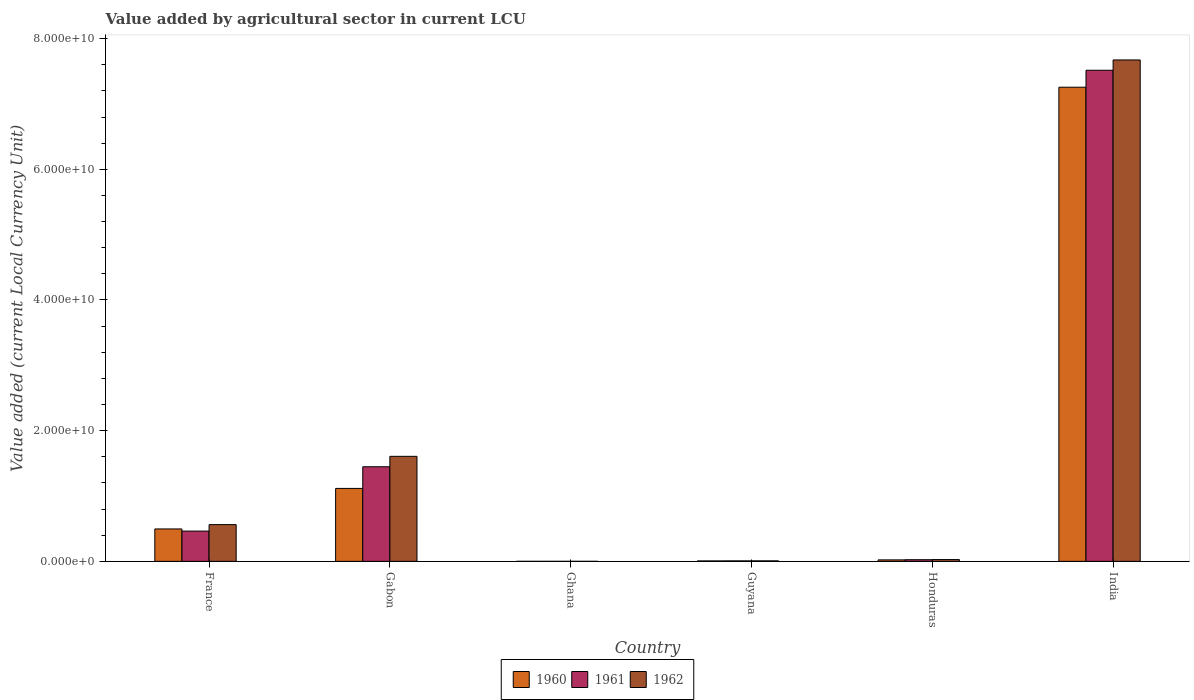How many groups of bars are there?
Offer a terse response. 6. Are the number of bars per tick equal to the number of legend labels?
Give a very brief answer. Yes. Are the number of bars on each tick of the X-axis equal?
Give a very brief answer. Yes. How many bars are there on the 4th tick from the left?
Ensure brevity in your answer.  3. How many bars are there on the 3rd tick from the right?
Provide a short and direct response. 3. What is the label of the 2nd group of bars from the left?
Your answer should be very brief. Gabon. What is the value added by agricultural sector in 1960 in India?
Your answer should be very brief. 7.26e+1. Across all countries, what is the maximum value added by agricultural sector in 1960?
Keep it short and to the point. 7.26e+1. Across all countries, what is the minimum value added by agricultural sector in 1960?
Provide a succinct answer. 3.55e+04. In which country was the value added by agricultural sector in 1962 maximum?
Your answer should be compact. India. In which country was the value added by agricultural sector in 1962 minimum?
Ensure brevity in your answer.  Ghana. What is the total value added by agricultural sector in 1962 in the graph?
Your answer should be compact. 9.88e+1. What is the difference between the value added by agricultural sector in 1961 in Gabon and that in India?
Provide a short and direct response. -6.07e+1. What is the difference between the value added by agricultural sector in 1960 in Ghana and the value added by agricultural sector in 1961 in India?
Provide a succinct answer. -7.52e+1. What is the average value added by agricultural sector in 1960 per country?
Your response must be concise. 1.48e+1. What is the difference between the value added by agricultural sector of/in 1962 and value added by agricultural sector of/in 1961 in France?
Your response must be concise. 9.90e+08. What is the ratio of the value added by agricultural sector in 1961 in Honduras to that in India?
Provide a succinct answer. 0. Is the value added by agricultural sector in 1960 in Gabon less than that in Ghana?
Make the answer very short. No. What is the difference between the highest and the second highest value added by agricultural sector in 1960?
Make the answer very short. 6.14e+1. What is the difference between the highest and the lowest value added by agricultural sector in 1962?
Ensure brevity in your answer.  7.67e+1. In how many countries, is the value added by agricultural sector in 1961 greater than the average value added by agricultural sector in 1961 taken over all countries?
Provide a short and direct response. 1. Is the sum of the value added by agricultural sector in 1960 in Gabon and India greater than the maximum value added by agricultural sector in 1961 across all countries?
Offer a terse response. Yes. What does the 1st bar from the left in Ghana represents?
Your response must be concise. 1960. What does the 2nd bar from the right in France represents?
Provide a short and direct response. 1961. Is it the case that in every country, the sum of the value added by agricultural sector in 1962 and value added by agricultural sector in 1961 is greater than the value added by agricultural sector in 1960?
Keep it short and to the point. Yes. Are all the bars in the graph horizontal?
Provide a short and direct response. No. How many countries are there in the graph?
Your answer should be very brief. 6. Are the values on the major ticks of Y-axis written in scientific E-notation?
Keep it short and to the point. Yes. Does the graph contain grids?
Offer a very short reply. No. How are the legend labels stacked?
Give a very brief answer. Horizontal. What is the title of the graph?
Your answer should be compact. Value added by agricultural sector in current LCU. What is the label or title of the Y-axis?
Your answer should be very brief. Value added (current Local Currency Unit). What is the Value added (current Local Currency Unit) of 1960 in France?
Make the answer very short. 4.96e+09. What is the Value added (current Local Currency Unit) in 1961 in France?
Your answer should be very brief. 4.63e+09. What is the Value added (current Local Currency Unit) of 1962 in France?
Your response must be concise. 5.62e+09. What is the Value added (current Local Currency Unit) of 1960 in Gabon?
Ensure brevity in your answer.  1.12e+1. What is the Value added (current Local Currency Unit) in 1961 in Gabon?
Offer a terse response. 1.45e+1. What is the Value added (current Local Currency Unit) in 1962 in Gabon?
Keep it short and to the point. 1.61e+1. What is the Value added (current Local Currency Unit) in 1960 in Ghana?
Offer a terse response. 3.55e+04. What is the Value added (current Local Currency Unit) of 1961 in Ghana?
Make the answer very short. 3.29e+04. What is the Value added (current Local Currency Unit) of 1962 in Ghana?
Make the answer very short. 3.74e+04. What is the Value added (current Local Currency Unit) in 1960 in Guyana?
Keep it short and to the point. 6.88e+07. What is the Value added (current Local Currency Unit) of 1961 in Guyana?
Offer a very short reply. 7.60e+07. What is the Value added (current Local Currency Unit) of 1962 in Guyana?
Your response must be concise. 7.84e+07. What is the Value added (current Local Currency Unit) in 1960 in Honduras?
Offer a very short reply. 2.27e+08. What is the Value added (current Local Currency Unit) in 1961 in Honduras?
Keep it short and to the point. 2.51e+08. What is the Value added (current Local Currency Unit) of 1962 in Honduras?
Your response must be concise. 2.74e+08. What is the Value added (current Local Currency Unit) of 1960 in India?
Offer a terse response. 7.26e+1. What is the Value added (current Local Currency Unit) in 1961 in India?
Provide a succinct answer. 7.52e+1. What is the Value added (current Local Currency Unit) of 1962 in India?
Ensure brevity in your answer.  7.67e+1. Across all countries, what is the maximum Value added (current Local Currency Unit) in 1960?
Offer a terse response. 7.26e+1. Across all countries, what is the maximum Value added (current Local Currency Unit) in 1961?
Your response must be concise. 7.52e+1. Across all countries, what is the maximum Value added (current Local Currency Unit) in 1962?
Keep it short and to the point. 7.67e+1. Across all countries, what is the minimum Value added (current Local Currency Unit) in 1960?
Your answer should be very brief. 3.55e+04. Across all countries, what is the minimum Value added (current Local Currency Unit) of 1961?
Ensure brevity in your answer.  3.29e+04. Across all countries, what is the minimum Value added (current Local Currency Unit) in 1962?
Provide a short and direct response. 3.74e+04. What is the total Value added (current Local Currency Unit) of 1960 in the graph?
Provide a short and direct response. 8.90e+1. What is the total Value added (current Local Currency Unit) in 1961 in the graph?
Keep it short and to the point. 9.46e+1. What is the total Value added (current Local Currency Unit) in 1962 in the graph?
Ensure brevity in your answer.  9.88e+1. What is the difference between the Value added (current Local Currency Unit) of 1960 in France and that in Gabon?
Your answer should be very brief. -6.20e+09. What is the difference between the Value added (current Local Currency Unit) in 1961 in France and that in Gabon?
Make the answer very short. -9.84e+09. What is the difference between the Value added (current Local Currency Unit) in 1962 in France and that in Gabon?
Your answer should be very brief. -1.04e+1. What is the difference between the Value added (current Local Currency Unit) in 1960 in France and that in Ghana?
Provide a succinct answer. 4.96e+09. What is the difference between the Value added (current Local Currency Unit) of 1961 in France and that in Ghana?
Provide a short and direct response. 4.63e+09. What is the difference between the Value added (current Local Currency Unit) in 1962 in France and that in Ghana?
Give a very brief answer. 5.62e+09. What is the difference between the Value added (current Local Currency Unit) of 1960 in France and that in Guyana?
Keep it short and to the point. 4.89e+09. What is the difference between the Value added (current Local Currency Unit) in 1961 in France and that in Guyana?
Offer a terse response. 4.56e+09. What is the difference between the Value added (current Local Currency Unit) in 1962 in France and that in Guyana?
Provide a succinct answer. 5.55e+09. What is the difference between the Value added (current Local Currency Unit) of 1960 in France and that in Honduras?
Offer a terse response. 4.73e+09. What is the difference between the Value added (current Local Currency Unit) of 1961 in France and that in Honduras?
Offer a very short reply. 4.38e+09. What is the difference between the Value added (current Local Currency Unit) of 1962 in France and that in Honduras?
Make the answer very short. 5.35e+09. What is the difference between the Value added (current Local Currency Unit) in 1960 in France and that in India?
Keep it short and to the point. -6.76e+1. What is the difference between the Value added (current Local Currency Unit) of 1961 in France and that in India?
Offer a terse response. -7.05e+1. What is the difference between the Value added (current Local Currency Unit) in 1962 in France and that in India?
Offer a terse response. -7.11e+1. What is the difference between the Value added (current Local Currency Unit) of 1960 in Gabon and that in Ghana?
Your response must be concise. 1.12e+1. What is the difference between the Value added (current Local Currency Unit) in 1961 in Gabon and that in Ghana?
Provide a succinct answer. 1.45e+1. What is the difference between the Value added (current Local Currency Unit) in 1962 in Gabon and that in Ghana?
Your response must be concise. 1.61e+1. What is the difference between the Value added (current Local Currency Unit) of 1960 in Gabon and that in Guyana?
Provide a short and direct response. 1.11e+1. What is the difference between the Value added (current Local Currency Unit) of 1961 in Gabon and that in Guyana?
Your answer should be very brief. 1.44e+1. What is the difference between the Value added (current Local Currency Unit) of 1962 in Gabon and that in Guyana?
Provide a succinct answer. 1.60e+1. What is the difference between the Value added (current Local Currency Unit) of 1960 in Gabon and that in Honduras?
Ensure brevity in your answer.  1.09e+1. What is the difference between the Value added (current Local Currency Unit) of 1961 in Gabon and that in Honduras?
Make the answer very short. 1.42e+1. What is the difference between the Value added (current Local Currency Unit) in 1962 in Gabon and that in Honduras?
Offer a terse response. 1.58e+1. What is the difference between the Value added (current Local Currency Unit) in 1960 in Gabon and that in India?
Make the answer very short. -6.14e+1. What is the difference between the Value added (current Local Currency Unit) of 1961 in Gabon and that in India?
Give a very brief answer. -6.07e+1. What is the difference between the Value added (current Local Currency Unit) of 1962 in Gabon and that in India?
Provide a short and direct response. -6.07e+1. What is the difference between the Value added (current Local Currency Unit) in 1960 in Ghana and that in Guyana?
Offer a very short reply. -6.88e+07. What is the difference between the Value added (current Local Currency Unit) of 1961 in Ghana and that in Guyana?
Your answer should be compact. -7.60e+07. What is the difference between the Value added (current Local Currency Unit) of 1962 in Ghana and that in Guyana?
Provide a succinct answer. -7.84e+07. What is the difference between the Value added (current Local Currency Unit) in 1960 in Ghana and that in Honduras?
Provide a short and direct response. -2.27e+08. What is the difference between the Value added (current Local Currency Unit) in 1961 in Ghana and that in Honduras?
Ensure brevity in your answer.  -2.51e+08. What is the difference between the Value added (current Local Currency Unit) of 1962 in Ghana and that in Honduras?
Provide a short and direct response. -2.74e+08. What is the difference between the Value added (current Local Currency Unit) in 1960 in Ghana and that in India?
Offer a very short reply. -7.26e+1. What is the difference between the Value added (current Local Currency Unit) in 1961 in Ghana and that in India?
Make the answer very short. -7.52e+1. What is the difference between the Value added (current Local Currency Unit) in 1962 in Ghana and that in India?
Keep it short and to the point. -7.67e+1. What is the difference between the Value added (current Local Currency Unit) of 1960 in Guyana and that in Honduras?
Your response must be concise. -1.58e+08. What is the difference between the Value added (current Local Currency Unit) in 1961 in Guyana and that in Honduras?
Ensure brevity in your answer.  -1.75e+08. What is the difference between the Value added (current Local Currency Unit) of 1962 in Guyana and that in Honduras?
Provide a succinct answer. -1.96e+08. What is the difference between the Value added (current Local Currency Unit) of 1960 in Guyana and that in India?
Your response must be concise. -7.25e+1. What is the difference between the Value added (current Local Currency Unit) of 1961 in Guyana and that in India?
Give a very brief answer. -7.51e+1. What is the difference between the Value added (current Local Currency Unit) of 1962 in Guyana and that in India?
Keep it short and to the point. -7.67e+1. What is the difference between the Value added (current Local Currency Unit) in 1960 in Honduras and that in India?
Ensure brevity in your answer.  -7.23e+1. What is the difference between the Value added (current Local Currency Unit) in 1961 in Honduras and that in India?
Your answer should be compact. -7.49e+1. What is the difference between the Value added (current Local Currency Unit) of 1962 in Honduras and that in India?
Your answer should be compact. -7.65e+1. What is the difference between the Value added (current Local Currency Unit) of 1960 in France and the Value added (current Local Currency Unit) of 1961 in Gabon?
Provide a succinct answer. -9.52e+09. What is the difference between the Value added (current Local Currency Unit) of 1960 in France and the Value added (current Local Currency Unit) of 1962 in Gabon?
Offer a terse response. -1.11e+1. What is the difference between the Value added (current Local Currency Unit) of 1961 in France and the Value added (current Local Currency Unit) of 1962 in Gabon?
Provide a short and direct response. -1.14e+1. What is the difference between the Value added (current Local Currency Unit) in 1960 in France and the Value added (current Local Currency Unit) in 1961 in Ghana?
Provide a succinct answer. 4.96e+09. What is the difference between the Value added (current Local Currency Unit) in 1960 in France and the Value added (current Local Currency Unit) in 1962 in Ghana?
Offer a very short reply. 4.96e+09. What is the difference between the Value added (current Local Currency Unit) in 1961 in France and the Value added (current Local Currency Unit) in 1962 in Ghana?
Keep it short and to the point. 4.63e+09. What is the difference between the Value added (current Local Currency Unit) of 1960 in France and the Value added (current Local Currency Unit) of 1961 in Guyana?
Your answer should be very brief. 4.88e+09. What is the difference between the Value added (current Local Currency Unit) of 1960 in France and the Value added (current Local Currency Unit) of 1962 in Guyana?
Your answer should be very brief. 4.88e+09. What is the difference between the Value added (current Local Currency Unit) of 1961 in France and the Value added (current Local Currency Unit) of 1962 in Guyana?
Your answer should be very brief. 4.56e+09. What is the difference between the Value added (current Local Currency Unit) in 1960 in France and the Value added (current Local Currency Unit) in 1961 in Honduras?
Ensure brevity in your answer.  4.71e+09. What is the difference between the Value added (current Local Currency Unit) in 1960 in France and the Value added (current Local Currency Unit) in 1962 in Honduras?
Your answer should be very brief. 4.69e+09. What is the difference between the Value added (current Local Currency Unit) in 1961 in France and the Value added (current Local Currency Unit) in 1962 in Honduras?
Your answer should be compact. 4.36e+09. What is the difference between the Value added (current Local Currency Unit) in 1960 in France and the Value added (current Local Currency Unit) in 1961 in India?
Make the answer very short. -7.02e+1. What is the difference between the Value added (current Local Currency Unit) in 1960 in France and the Value added (current Local Currency Unit) in 1962 in India?
Make the answer very short. -7.18e+1. What is the difference between the Value added (current Local Currency Unit) of 1961 in France and the Value added (current Local Currency Unit) of 1962 in India?
Make the answer very short. -7.21e+1. What is the difference between the Value added (current Local Currency Unit) in 1960 in Gabon and the Value added (current Local Currency Unit) in 1961 in Ghana?
Provide a succinct answer. 1.12e+1. What is the difference between the Value added (current Local Currency Unit) in 1960 in Gabon and the Value added (current Local Currency Unit) in 1962 in Ghana?
Your answer should be very brief. 1.12e+1. What is the difference between the Value added (current Local Currency Unit) of 1961 in Gabon and the Value added (current Local Currency Unit) of 1962 in Ghana?
Give a very brief answer. 1.45e+1. What is the difference between the Value added (current Local Currency Unit) of 1960 in Gabon and the Value added (current Local Currency Unit) of 1961 in Guyana?
Provide a short and direct response. 1.11e+1. What is the difference between the Value added (current Local Currency Unit) of 1960 in Gabon and the Value added (current Local Currency Unit) of 1962 in Guyana?
Ensure brevity in your answer.  1.11e+1. What is the difference between the Value added (current Local Currency Unit) in 1961 in Gabon and the Value added (current Local Currency Unit) in 1962 in Guyana?
Your response must be concise. 1.44e+1. What is the difference between the Value added (current Local Currency Unit) in 1960 in Gabon and the Value added (current Local Currency Unit) in 1961 in Honduras?
Your response must be concise. 1.09e+1. What is the difference between the Value added (current Local Currency Unit) of 1960 in Gabon and the Value added (current Local Currency Unit) of 1962 in Honduras?
Give a very brief answer. 1.09e+1. What is the difference between the Value added (current Local Currency Unit) in 1961 in Gabon and the Value added (current Local Currency Unit) in 1962 in Honduras?
Make the answer very short. 1.42e+1. What is the difference between the Value added (current Local Currency Unit) in 1960 in Gabon and the Value added (current Local Currency Unit) in 1961 in India?
Your answer should be very brief. -6.40e+1. What is the difference between the Value added (current Local Currency Unit) in 1960 in Gabon and the Value added (current Local Currency Unit) in 1962 in India?
Your response must be concise. -6.56e+1. What is the difference between the Value added (current Local Currency Unit) in 1961 in Gabon and the Value added (current Local Currency Unit) in 1962 in India?
Ensure brevity in your answer.  -6.23e+1. What is the difference between the Value added (current Local Currency Unit) in 1960 in Ghana and the Value added (current Local Currency Unit) in 1961 in Guyana?
Keep it short and to the point. -7.60e+07. What is the difference between the Value added (current Local Currency Unit) in 1960 in Ghana and the Value added (current Local Currency Unit) in 1962 in Guyana?
Offer a very short reply. -7.84e+07. What is the difference between the Value added (current Local Currency Unit) of 1961 in Ghana and the Value added (current Local Currency Unit) of 1962 in Guyana?
Provide a short and direct response. -7.84e+07. What is the difference between the Value added (current Local Currency Unit) of 1960 in Ghana and the Value added (current Local Currency Unit) of 1961 in Honduras?
Offer a terse response. -2.51e+08. What is the difference between the Value added (current Local Currency Unit) in 1960 in Ghana and the Value added (current Local Currency Unit) in 1962 in Honduras?
Give a very brief answer. -2.74e+08. What is the difference between the Value added (current Local Currency Unit) of 1961 in Ghana and the Value added (current Local Currency Unit) of 1962 in Honduras?
Your answer should be very brief. -2.74e+08. What is the difference between the Value added (current Local Currency Unit) of 1960 in Ghana and the Value added (current Local Currency Unit) of 1961 in India?
Your answer should be very brief. -7.52e+1. What is the difference between the Value added (current Local Currency Unit) of 1960 in Ghana and the Value added (current Local Currency Unit) of 1962 in India?
Provide a short and direct response. -7.67e+1. What is the difference between the Value added (current Local Currency Unit) in 1961 in Ghana and the Value added (current Local Currency Unit) in 1962 in India?
Your answer should be compact. -7.67e+1. What is the difference between the Value added (current Local Currency Unit) of 1960 in Guyana and the Value added (current Local Currency Unit) of 1961 in Honduras?
Offer a very short reply. -1.82e+08. What is the difference between the Value added (current Local Currency Unit) of 1960 in Guyana and the Value added (current Local Currency Unit) of 1962 in Honduras?
Provide a succinct answer. -2.06e+08. What is the difference between the Value added (current Local Currency Unit) in 1961 in Guyana and the Value added (current Local Currency Unit) in 1962 in Honduras?
Ensure brevity in your answer.  -1.98e+08. What is the difference between the Value added (current Local Currency Unit) in 1960 in Guyana and the Value added (current Local Currency Unit) in 1961 in India?
Offer a very short reply. -7.51e+1. What is the difference between the Value added (current Local Currency Unit) of 1960 in Guyana and the Value added (current Local Currency Unit) of 1962 in India?
Your answer should be very brief. -7.67e+1. What is the difference between the Value added (current Local Currency Unit) in 1961 in Guyana and the Value added (current Local Currency Unit) in 1962 in India?
Give a very brief answer. -7.67e+1. What is the difference between the Value added (current Local Currency Unit) in 1960 in Honduras and the Value added (current Local Currency Unit) in 1961 in India?
Offer a terse response. -7.49e+1. What is the difference between the Value added (current Local Currency Unit) of 1960 in Honduras and the Value added (current Local Currency Unit) of 1962 in India?
Your answer should be compact. -7.65e+1. What is the difference between the Value added (current Local Currency Unit) in 1961 in Honduras and the Value added (current Local Currency Unit) in 1962 in India?
Provide a short and direct response. -7.65e+1. What is the average Value added (current Local Currency Unit) in 1960 per country?
Your answer should be compact. 1.48e+1. What is the average Value added (current Local Currency Unit) in 1961 per country?
Your answer should be very brief. 1.58e+1. What is the average Value added (current Local Currency Unit) in 1962 per country?
Offer a terse response. 1.65e+1. What is the difference between the Value added (current Local Currency Unit) in 1960 and Value added (current Local Currency Unit) in 1961 in France?
Keep it short and to the point. 3.26e+08. What is the difference between the Value added (current Local Currency Unit) in 1960 and Value added (current Local Currency Unit) in 1962 in France?
Your response must be concise. -6.64e+08. What is the difference between the Value added (current Local Currency Unit) in 1961 and Value added (current Local Currency Unit) in 1962 in France?
Keep it short and to the point. -9.90e+08. What is the difference between the Value added (current Local Currency Unit) of 1960 and Value added (current Local Currency Unit) of 1961 in Gabon?
Make the answer very short. -3.31e+09. What is the difference between the Value added (current Local Currency Unit) of 1960 and Value added (current Local Currency Unit) of 1962 in Gabon?
Keep it short and to the point. -4.91e+09. What is the difference between the Value added (current Local Currency Unit) in 1961 and Value added (current Local Currency Unit) in 1962 in Gabon?
Give a very brief answer. -1.59e+09. What is the difference between the Value added (current Local Currency Unit) in 1960 and Value added (current Local Currency Unit) in 1961 in Ghana?
Your answer should be very brief. 2600. What is the difference between the Value added (current Local Currency Unit) in 1960 and Value added (current Local Currency Unit) in 1962 in Ghana?
Your answer should be very brief. -1900. What is the difference between the Value added (current Local Currency Unit) in 1961 and Value added (current Local Currency Unit) in 1962 in Ghana?
Ensure brevity in your answer.  -4500. What is the difference between the Value added (current Local Currency Unit) of 1960 and Value added (current Local Currency Unit) of 1961 in Guyana?
Give a very brief answer. -7.20e+06. What is the difference between the Value added (current Local Currency Unit) of 1960 and Value added (current Local Currency Unit) of 1962 in Guyana?
Your response must be concise. -9.60e+06. What is the difference between the Value added (current Local Currency Unit) of 1961 and Value added (current Local Currency Unit) of 1962 in Guyana?
Offer a terse response. -2.40e+06. What is the difference between the Value added (current Local Currency Unit) in 1960 and Value added (current Local Currency Unit) in 1961 in Honduras?
Offer a terse response. -2.42e+07. What is the difference between the Value added (current Local Currency Unit) of 1960 and Value added (current Local Currency Unit) of 1962 in Honduras?
Give a very brief answer. -4.75e+07. What is the difference between the Value added (current Local Currency Unit) of 1961 and Value added (current Local Currency Unit) of 1962 in Honduras?
Your answer should be very brief. -2.33e+07. What is the difference between the Value added (current Local Currency Unit) in 1960 and Value added (current Local Currency Unit) in 1961 in India?
Offer a terse response. -2.59e+09. What is the difference between the Value added (current Local Currency Unit) in 1960 and Value added (current Local Currency Unit) in 1962 in India?
Give a very brief answer. -4.17e+09. What is the difference between the Value added (current Local Currency Unit) of 1961 and Value added (current Local Currency Unit) of 1962 in India?
Offer a very short reply. -1.58e+09. What is the ratio of the Value added (current Local Currency Unit) in 1960 in France to that in Gabon?
Offer a terse response. 0.44. What is the ratio of the Value added (current Local Currency Unit) in 1961 in France to that in Gabon?
Your answer should be compact. 0.32. What is the ratio of the Value added (current Local Currency Unit) in 1962 in France to that in Gabon?
Provide a short and direct response. 0.35. What is the ratio of the Value added (current Local Currency Unit) in 1960 in France to that in Ghana?
Offer a very short reply. 1.40e+05. What is the ratio of the Value added (current Local Currency Unit) of 1961 in France to that in Ghana?
Offer a very short reply. 1.41e+05. What is the ratio of the Value added (current Local Currency Unit) in 1962 in France to that in Ghana?
Provide a short and direct response. 1.50e+05. What is the ratio of the Value added (current Local Currency Unit) of 1960 in France to that in Guyana?
Offer a terse response. 72.09. What is the ratio of the Value added (current Local Currency Unit) of 1961 in France to that in Guyana?
Your answer should be compact. 60.97. What is the ratio of the Value added (current Local Currency Unit) of 1962 in France to that in Guyana?
Your answer should be very brief. 71.73. What is the ratio of the Value added (current Local Currency Unit) in 1960 in France to that in Honduras?
Your answer should be very brief. 21.85. What is the ratio of the Value added (current Local Currency Unit) of 1961 in France to that in Honduras?
Make the answer very short. 18.45. What is the ratio of the Value added (current Local Currency Unit) of 1962 in France to that in Honduras?
Give a very brief answer. 20.49. What is the ratio of the Value added (current Local Currency Unit) in 1960 in France to that in India?
Give a very brief answer. 0.07. What is the ratio of the Value added (current Local Currency Unit) of 1961 in France to that in India?
Offer a terse response. 0.06. What is the ratio of the Value added (current Local Currency Unit) in 1962 in France to that in India?
Provide a short and direct response. 0.07. What is the ratio of the Value added (current Local Currency Unit) in 1960 in Gabon to that in Ghana?
Give a very brief answer. 3.14e+05. What is the ratio of the Value added (current Local Currency Unit) in 1961 in Gabon to that in Ghana?
Your response must be concise. 4.40e+05. What is the ratio of the Value added (current Local Currency Unit) of 1962 in Gabon to that in Ghana?
Provide a short and direct response. 4.30e+05. What is the ratio of the Value added (current Local Currency Unit) of 1960 in Gabon to that in Guyana?
Your answer should be compact. 162.28. What is the ratio of the Value added (current Local Currency Unit) of 1961 in Gabon to that in Guyana?
Ensure brevity in your answer.  190.49. What is the ratio of the Value added (current Local Currency Unit) in 1962 in Gabon to that in Guyana?
Your response must be concise. 205. What is the ratio of the Value added (current Local Currency Unit) of 1960 in Gabon to that in Honduras?
Keep it short and to the point. 49.18. What is the ratio of the Value added (current Local Currency Unit) of 1961 in Gabon to that in Honduras?
Make the answer very short. 57.63. What is the ratio of the Value added (current Local Currency Unit) in 1962 in Gabon to that in Honduras?
Keep it short and to the point. 58.55. What is the ratio of the Value added (current Local Currency Unit) in 1960 in Gabon to that in India?
Offer a terse response. 0.15. What is the ratio of the Value added (current Local Currency Unit) of 1961 in Gabon to that in India?
Make the answer very short. 0.19. What is the ratio of the Value added (current Local Currency Unit) of 1962 in Gabon to that in India?
Give a very brief answer. 0.21. What is the ratio of the Value added (current Local Currency Unit) of 1961 in Ghana to that in Honduras?
Give a very brief answer. 0. What is the ratio of the Value added (current Local Currency Unit) in 1960 in Ghana to that in India?
Your answer should be very brief. 0. What is the ratio of the Value added (current Local Currency Unit) in 1961 in Ghana to that in India?
Make the answer very short. 0. What is the ratio of the Value added (current Local Currency Unit) in 1960 in Guyana to that in Honduras?
Your answer should be very brief. 0.3. What is the ratio of the Value added (current Local Currency Unit) in 1961 in Guyana to that in Honduras?
Your answer should be compact. 0.3. What is the ratio of the Value added (current Local Currency Unit) in 1962 in Guyana to that in Honduras?
Offer a terse response. 0.29. What is the ratio of the Value added (current Local Currency Unit) in 1960 in Guyana to that in India?
Provide a short and direct response. 0. What is the ratio of the Value added (current Local Currency Unit) in 1961 in Guyana to that in India?
Ensure brevity in your answer.  0. What is the ratio of the Value added (current Local Currency Unit) in 1962 in Guyana to that in India?
Provide a short and direct response. 0. What is the ratio of the Value added (current Local Currency Unit) of 1960 in Honduras to that in India?
Give a very brief answer. 0. What is the ratio of the Value added (current Local Currency Unit) in 1961 in Honduras to that in India?
Keep it short and to the point. 0. What is the ratio of the Value added (current Local Currency Unit) in 1962 in Honduras to that in India?
Provide a short and direct response. 0. What is the difference between the highest and the second highest Value added (current Local Currency Unit) in 1960?
Offer a terse response. 6.14e+1. What is the difference between the highest and the second highest Value added (current Local Currency Unit) in 1961?
Provide a succinct answer. 6.07e+1. What is the difference between the highest and the second highest Value added (current Local Currency Unit) of 1962?
Your answer should be compact. 6.07e+1. What is the difference between the highest and the lowest Value added (current Local Currency Unit) of 1960?
Keep it short and to the point. 7.26e+1. What is the difference between the highest and the lowest Value added (current Local Currency Unit) in 1961?
Your response must be concise. 7.52e+1. What is the difference between the highest and the lowest Value added (current Local Currency Unit) in 1962?
Provide a succinct answer. 7.67e+1. 